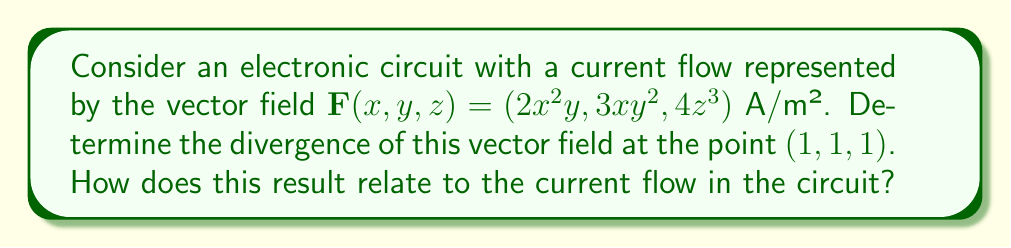Help me with this question. To solve this problem, we'll follow these steps:

1) The divergence of a vector field $\mathbf{F}(x, y, z) = (F_x, F_y, F_z)$ is given by:

   $$\nabla \cdot \mathbf{F} = \frac{\partial F_x}{\partial x} + \frac{\partial F_y}{\partial y} + \frac{\partial F_z}{\partial z}$$

2) For our vector field $\mathbf{F}(x, y, z) = (2x^2y, 3xy^2, 4z^3)$, we need to calculate:

   $$\frac{\partial F_x}{\partial x} = \frac{\partial}{\partial x}(2x^2y) = 4xy$$
   
   $$\frac{\partial F_y}{\partial y} = \frac{\partial}{\partial y}(3xy^2) = 6xy$$
   
   $$\frac{\partial F_z}{\partial z} = \frac{\partial}{\partial z}(4z^3) = 12z^2$$

3) Now, we can substitute these partial derivatives into the divergence formula:

   $$\nabla \cdot \mathbf{F} = 4xy + 6xy + 12z^2$$

4) To find the divergence at the point (1, 1, 1), we substitute x = 1, y = 1, and z = 1:

   $$\nabla \cdot \mathbf{F}|_{(1,1,1)} = 4(1)(1) + 6(1)(1) + 12(1)^2 = 4 + 6 + 12 = 22$$

5) In the context of electronic circuits, the divergence of the current density field represents the rate at which charge is accumulating or depleting at a point. A positive divergence (as we found here) indicates that charge is accumulating at the point (1, 1, 1) in the circuit. This could represent a region where current is flowing into a component or node, such as a capacitor charging or a junction where multiple current paths converge.

For an AVR microcontroller application, understanding this current flow behavior could be crucial when designing power distribution networks or analyzing electromagnetic interference in complex circuit layouts.
Answer: 22 A/m³, indicating charge accumulation at (1, 1, 1) 